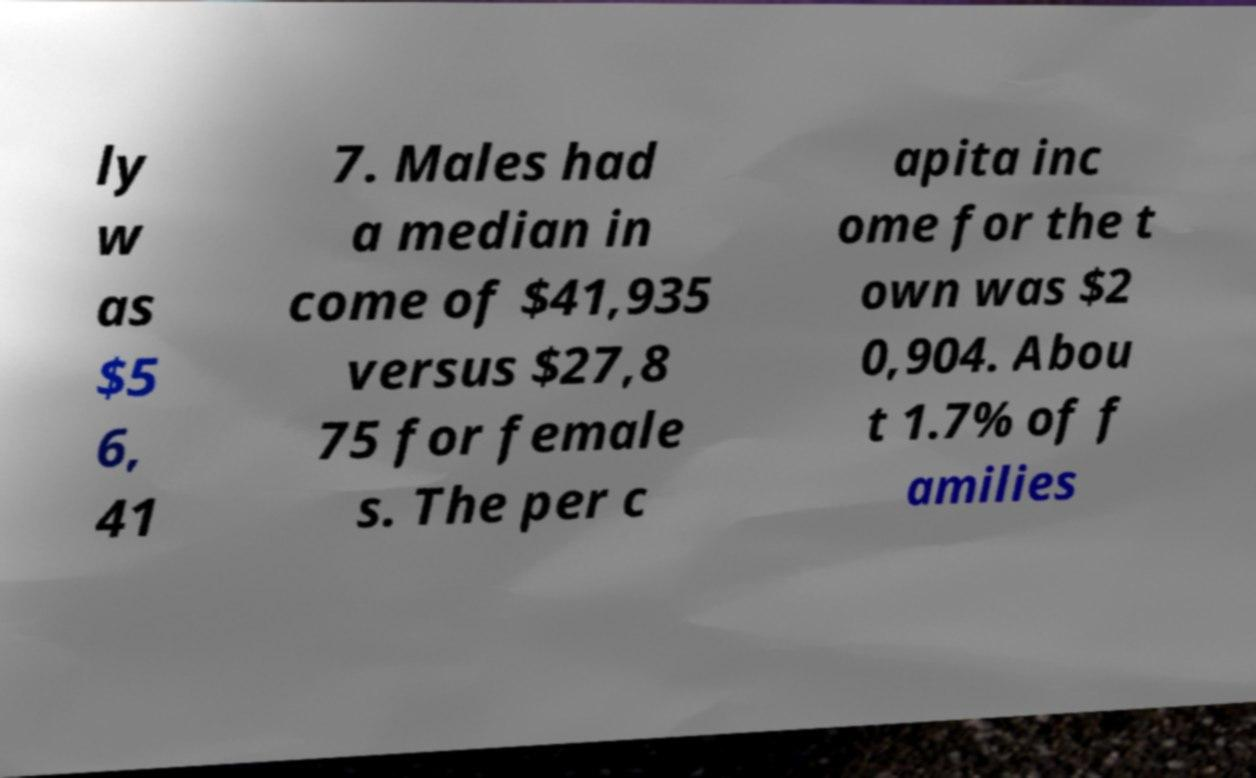I need the written content from this picture converted into text. Can you do that? ly w as $5 6, 41 7. Males had a median in come of $41,935 versus $27,8 75 for female s. The per c apita inc ome for the t own was $2 0,904. Abou t 1.7% of f amilies 